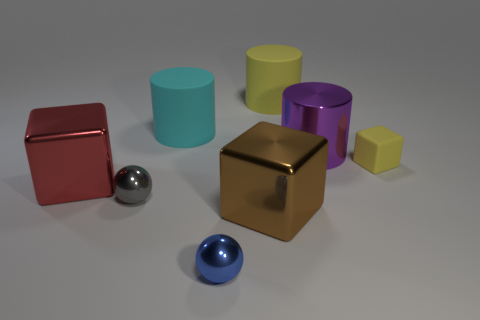Subtract all matte cylinders. How many cylinders are left? 1 Subtract all gray spheres. How many spheres are left? 1 Subtract 1 spheres. How many spheres are left? 1 Add 1 yellow cubes. How many objects exist? 9 Subtract all blue spheres. How many brown blocks are left? 1 Subtract 1 yellow cylinders. How many objects are left? 7 Subtract all cylinders. How many objects are left? 5 Subtract all blue blocks. Subtract all yellow cylinders. How many blocks are left? 3 Subtract all brown blocks. Subtract all large blocks. How many objects are left? 5 Add 7 metallic blocks. How many metallic blocks are left? 9 